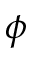Convert formula to latex. <formula><loc_0><loc_0><loc_500><loc_500>\phi</formula> 